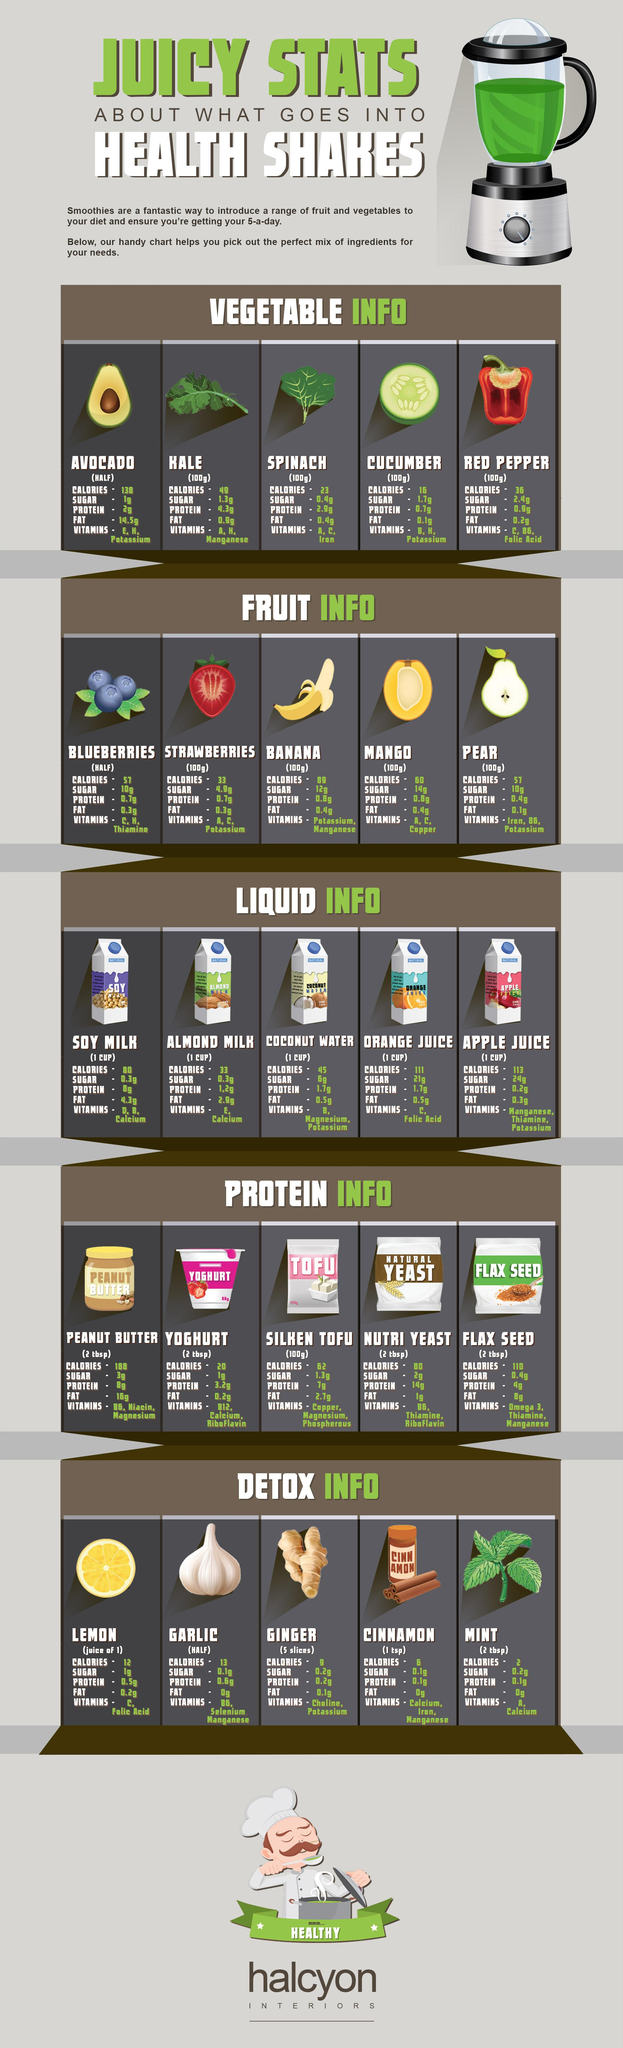Mention a couple of crucial points in this snapshot. Bananas contain the highest number of calories among all fruits. Silken tofu is typically measured in terms of its quantity, with 100 grams being a commonly used unit of measurement. The sum of fat in kale and spinach is approximately 1.3 grams. Garlic is a plant that contains several vitamins, including vitamin B6, selenium, and manganese. The quantity of cinnamon considered is one teaspoon. 